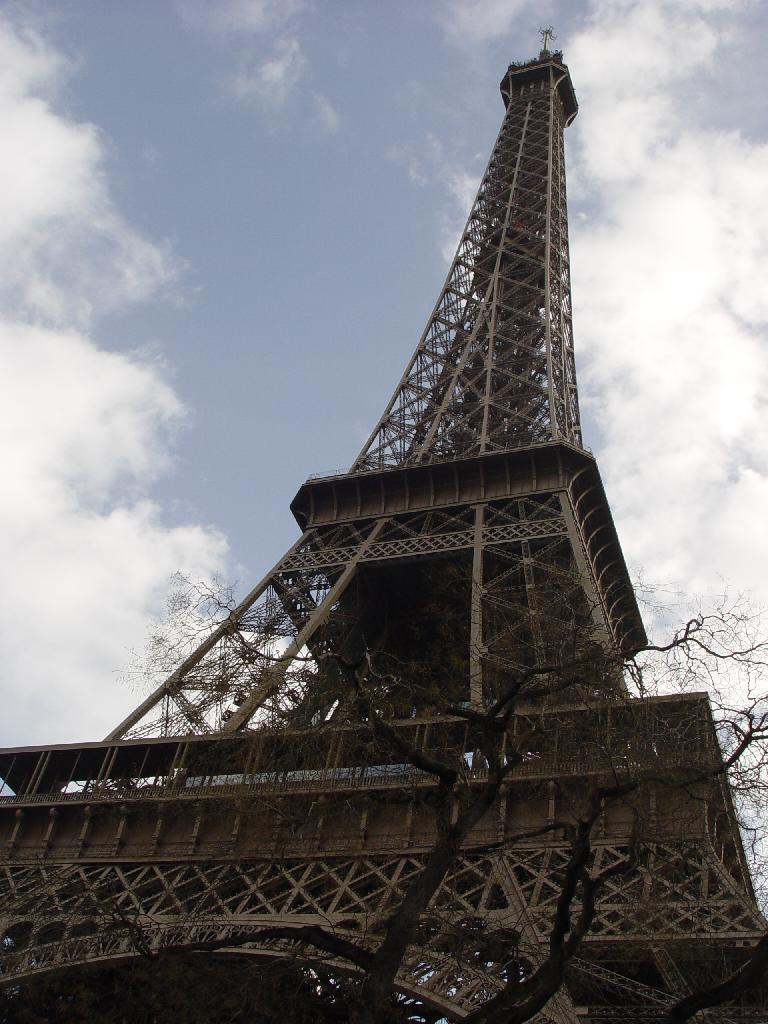What type of structure is in the image? There is a metallic tower in the image. What is the condition of the tree in the image? There is a dry tree in the image. What part of the natural environment is visible in the image? The sky is visible in the image. What can be seen in the sky? Clouds are present in the sky. Where are the crayons located in the image? There are no crayons present in the image. What type of furniture is visible in the image? There is no furniture visible in the image, only a metallic tower and a dry tree. 